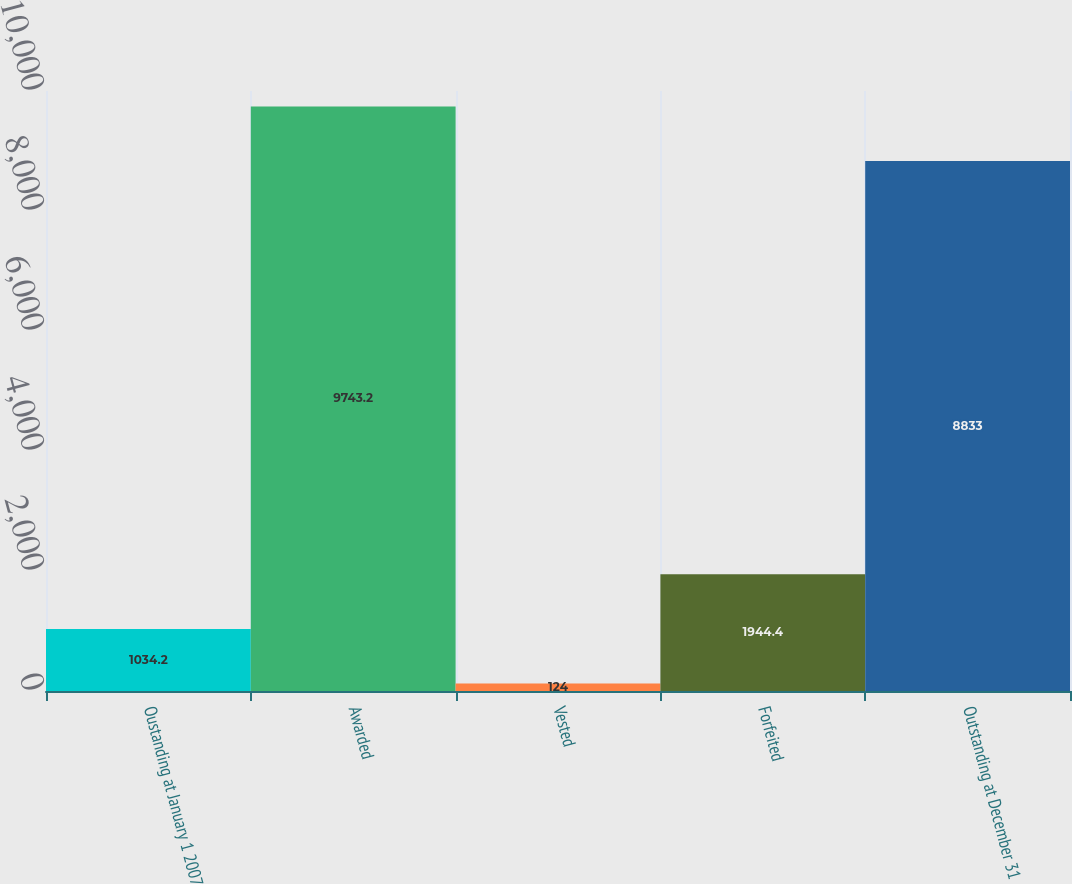Convert chart to OTSL. <chart><loc_0><loc_0><loc_500><loc_500><bar_chart><fcel>Oustanding at January 1 2007<fcel>Awarded<fcel>Vested<fcel>Forfeited<fcel>Outstanding at December 31<nl><fcel>1034.2<fcel>9743.2<fcel>124<fcel>1944.4<fcel>8833<nl></chart> 